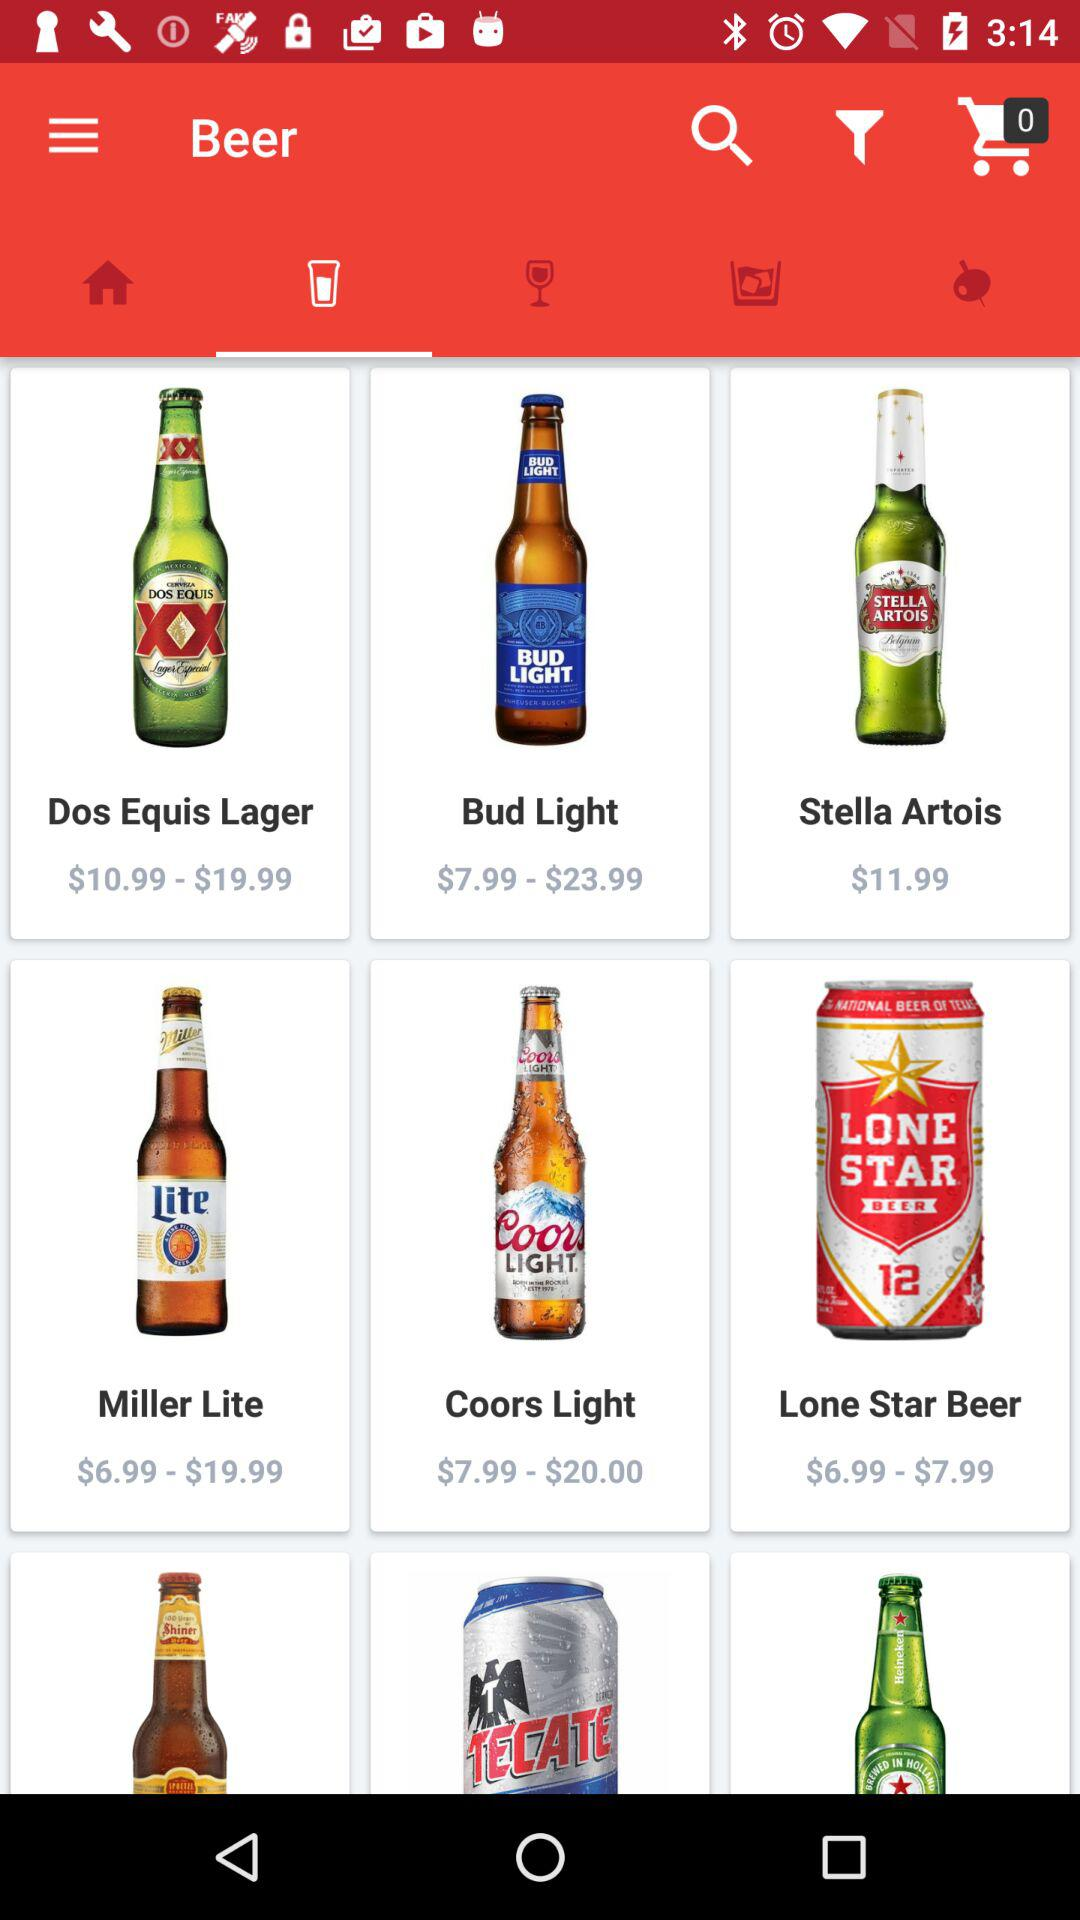How much more expensive is Stella Artois than Bud Light?
Answer the question using a single word or phrase. $4.00 